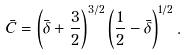Convert formula to latex. <formula><loc_0><loc_0><loc_500><loc_500>\bar { C } = \left ( \bar { \delta } + \frac { 3 } { 2 } \right ) ^ { 3 / 2 } \left ( \frac { 1 } { 2 } - \bar { \delta } \right ) ^ { 1 / 2 } .</formula> 